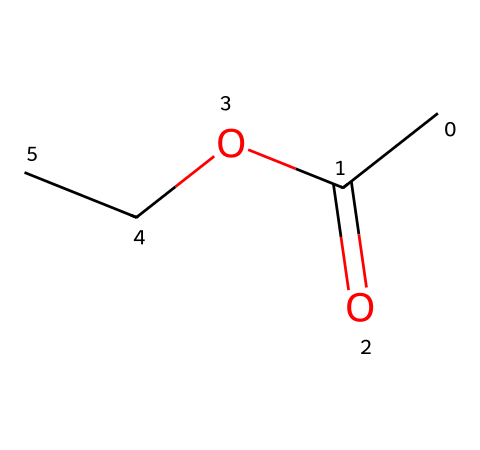What is the name of this chemical? The SMILES representation translates to a chemical commonly known as ethyl acetate, which is an ester.
Answer: ethyl acetate How many carbon atoms are in the structure? From the SMILES, there are four carbon atoms (two from the ethyl group and one from the acetate group).
Answer: four How many oxygen atoms are in the structure? The SMILES shows two oxygen atoms, one as part of the carbonyl group and the other in the ester bond.
Answer: two Which part of the structure corresponds to the ester functional group? The ester functional group is identified by the presence of the carbonyl oxygen (C=O) bonded to another oxygen (O-). This is typical in esters.
Answer: carbonyl and alkoxy groups What is the functional group present in ethyl acetate? The chemical structure indicates that it contains an ester functional group due to its combination of a carbonyl and an alkoxy group.
Answer: ester What type of bonding is present between the carbon and oxygen in the carbonyl group? The bond between carbon and oxygen in the carbonyl group is a double bond, which can be deduced from the structure indicated by the "C(=O)" notation in the SMILES.
Answer: double bond What is the molecular formula of ethyl acetate based on the structure? By counting the atoms in the SMILES notation, we can deduce that the molecular formula is C4H8O2, indicating that it contains four carbons, eight hydrogens, and two oxygens.
Answer: C4H8O2 